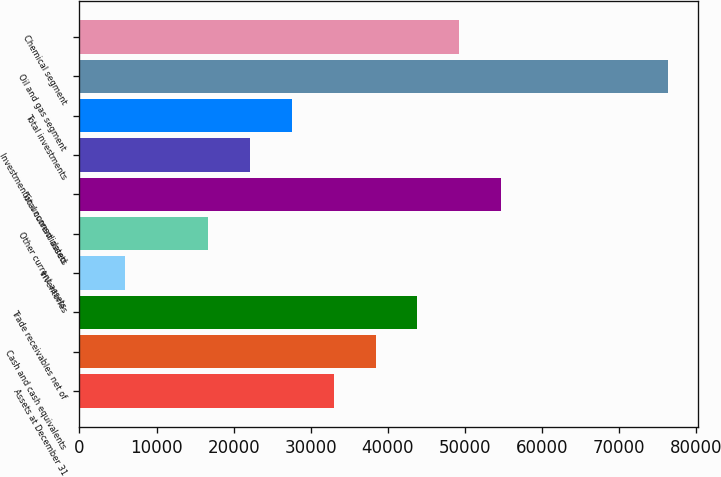<chart> <loc_0><loc_0><loc_500><loc_500><bar_chart><fcel>Assets at December 31<fcel>Cash and cash equivalents<fcel>Trade receivables net of<fcel>Inventories<fcel>Other current assets<fcel>Total current assets<fcel>Investment in unconsolidated<fcel>Total investments<fcel>Oil and gas segment<fcel>Chemical segment<nl><fcel>32993.4<fcel>38413.3<fcel>43833.2<fcel>5893.9<fcel>16733.7<fcel>54673<fcel>22153.6<fcel>27573.5<fcel>76352.6<fcel>49253.1<nl></chart> 